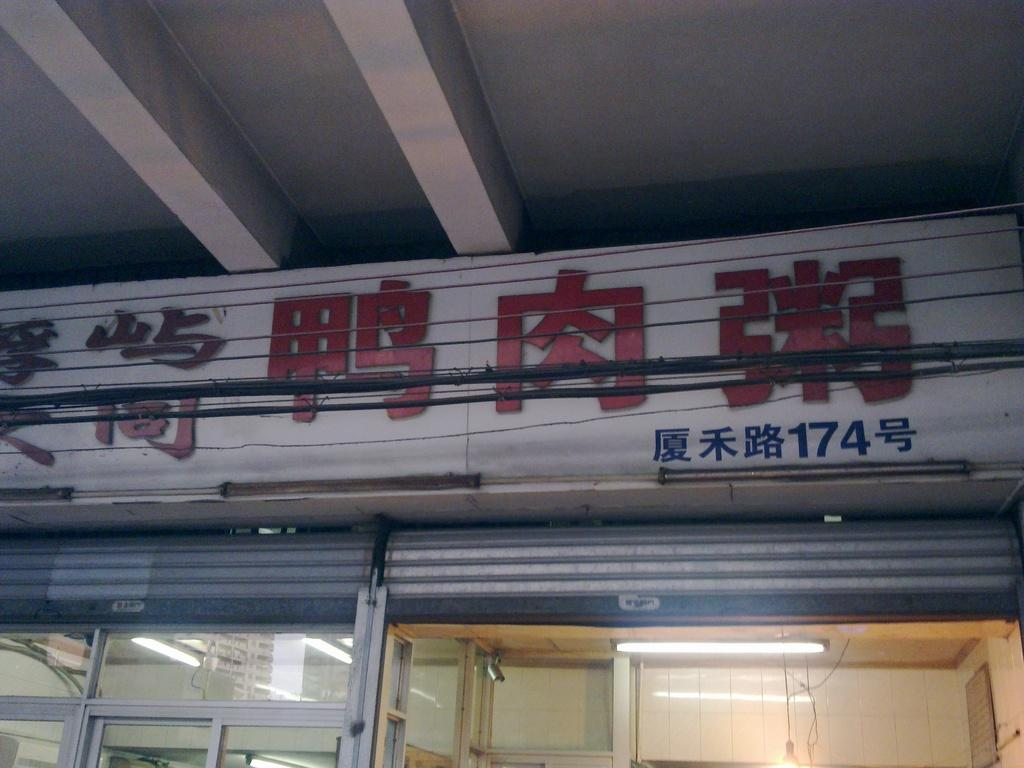What type of objects can be seen in the image? There are cables, a hoarding, lights, rolling shutters, glasses, and a camera in the image. Can you describe the hoarding in the image? The hoarding is a large sign or advertisement that is visible in the image. What might the lights be used for in the image? The lights could be used for illumination or decoration in the area. What type of object is used to cover windows or doors in the image? Rolling shutters are used to cover windows or doors in the image. What objects might be used for viewing or capturing images in the image? The glasses and camera in the image might be used for viewing or capturing images. What type of wood can be seen in the image? There is no wood present in the image. What subject is being taught in the image? There is no teaching or classroom scene depicted in the image. 